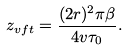<formula> <loc_0><loc_0><loc_500><loc_500>z _ { v f t } = \frac { ( 2 r ) ^ { 2 } \pi \beta } { 4 v \tau _ { 0 } } .</formula> 